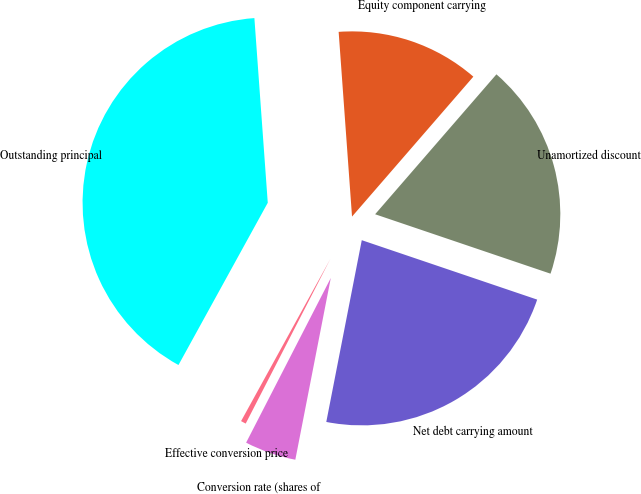Convert chart to OTSL. <chart><loc_0><loc_0><loc_500><loc_500><pie_chart><fcel>Outstanding principal<fcel>Equity component carrying<fcel>Unamortized discount<fcel>Net debt carrying amount<fcel>Conversion rate (shares of<fcel>Effective conversion price<nl><fcel>40.84%<fcel>12.52%<fcel>18.83%<fcel>22.87%<fcel>4.49%<fcel>0.45%<nl></chart> 